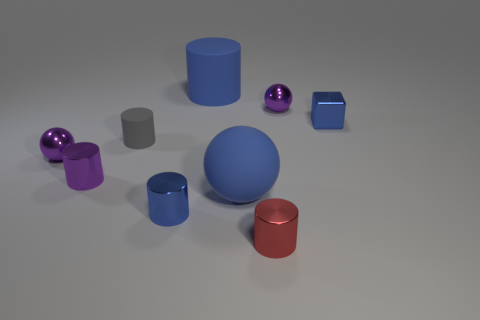Subtract all purple cylinders. How many cylinders are left? 4 Add 1 green rubber spheres. How many objects exist? 10 Subtract all purple spheres. How many spheres are left? 1 Subtract 3 cylinders. How many cylinders are left? 2 Add 9 purple metal cylinders. How many purple metal cylinders are left? 10 Add 5 large brown rubber balls. How many large brown rubber balls exist? 5 Subtract 0 cyan cubes. How many objects are left? 9 Subtract all cubes. How many objects are left? 8 Subtract all blue cylinders. Subtract all cyan spheres. How many cylinders are left? 3 Subtract all red balls. How many green cylinders are left? 0 